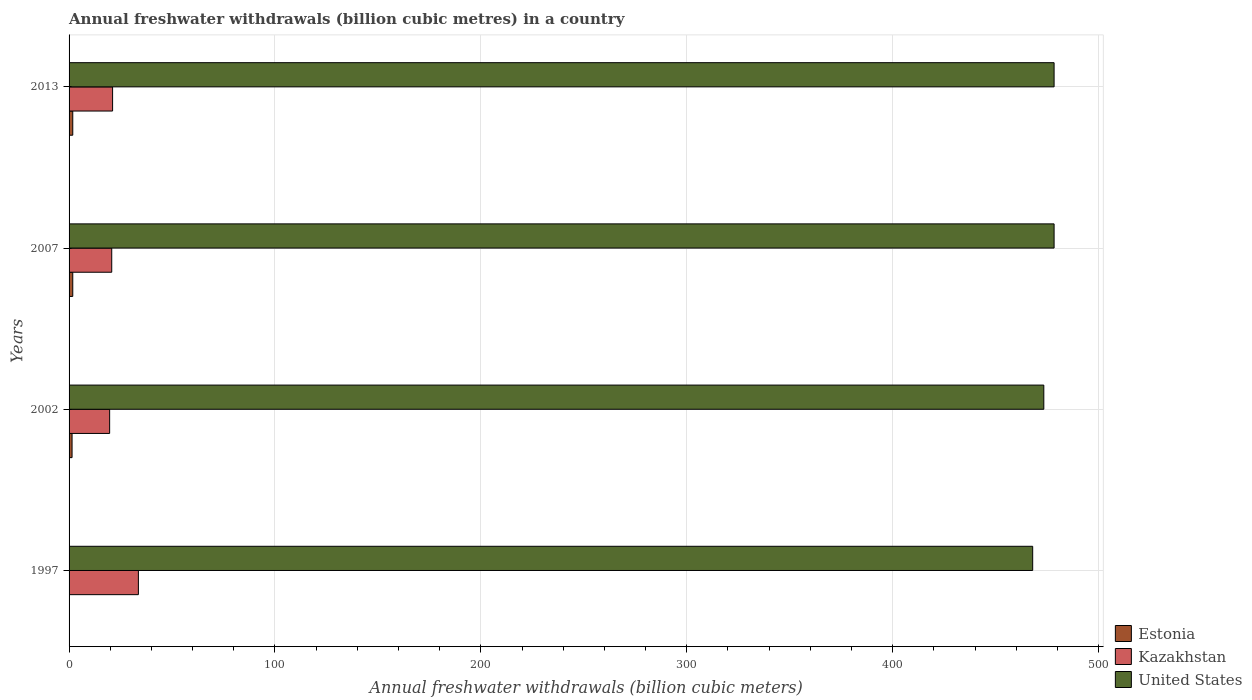How many bars are there on the 4th tick from the bottom?
Give a very brief answer. 3. What is the annual freshwater withdrawals in United States in 2013?
Your answer should be very brief. 478.4. Across all years, what is the maximum annual freshwater withdrawals in Kazakhstan?
Offer a very short reply. 33.67. Across all years, what is the minimum annual freshwater withdrawals in United States?
Your answer should be compact. 468. In which year was the annual freshwater withdrawals in Kazakhstan minimum?
Make the answer very short. 2002. What is the total annual freshwater withdrawals in Kazakhstan in the graph?
Keep it short and to the point. 95.23. What is the difference between the annual freshwater withdrawals in United States in 1997 and that in 2002?
Ensure brevity in your answer.  -5.4. What is the difference between the annual freshwater withdrawals in Kazakhstan in 2007 and the annual freshwater withdrawals in Estonia in 2002?
Your response must be concise. 19.26. What is the average annual freshwater withdrawals in Estonia per year?
Your answer should be compact. 1.3. In the year 1997, what is the difference between the annual freshwater withdrawals in United States and annual freshwater withdrawals in Kazakhstan?
Offer a terse response. 434.33. What is the ratio of the annual freshwater withdrawals in United States in 1997 to that in 2007?
Make the answer very short. 0.98. What is the difference between the highest and the second highest annual freshwater withdrawals in United States?
Provide a short and direct response. 0. What is the difference between the highest and the lowest annual freshwater withdrawals in Kazakhstan?
Keep it short and to the point. 13.97. What does the 2nd bar from the top in 2002 represents?
Your answer should be compact. Kazakhstan. What does the 2nd bar from the bottom in 2002 represents?
Your response must be concise. Kazakhstan. Is it the case that in every year, the sum of the annual freshwater withdrawals in United States and annual freshwater withdrawals in Kazakhstan is greater than the annual freshwater withdrawals in Estonia?
Make the answer very short. Yes. How many bars are there?
Make the answer very short. 12. Are all the bars in the graph horizontal?
Your answer should be compact. Yes. What is the difference between two consecutive major ticks on the X-axis?
Provide a succinct answer. 100. Are the values on the major ticks of X-axis written in scientific E-notation?
Offer a very short reply. No. Does the graph contain grids?
Make the answer very short. Yes. Where does the legend appear in the graph?
Your response must be concise. Bottom right. What is the title of the graph?
Provide a short and direct response. Annual freshwater withdrawals (billion cubic metres) in a country. Does "Ghana" appear as one of the legend labels in the graph?
Give a very brief answer. No. What is the label or title of the X-axis?
Provide a short and direct response. Annual freshwater withdrawals (billion cubic meters). What is the Annual freshwater withdrawals (billion cubic meters) of Estonia in 1997?
Give a very brief answer. 0.16. What is the Annual freshwater withdrawals (billion cubic meters) of Kazakhstan in 1997?
Your response must be concise. 33.67. What is the Annual freshwater withdrawals (billion cubic meters) of United States in 1997?
Offer a very short reply. 468. What is the Annual freshwater withdrawals (billion cubic meters) in Estonia in 2002?
Ensure brevity in your answer.  1.46. What is the Annual freshwater withdrawals (billion cubic meters) in United States in 2002?
Keep it short and to the point. 473.4. What is the Annual freshwater withdrawals (billion cubic meters) in Estonia in 2007?
Give a very brief answer. 1.8. What is the Annual freshwater withdrawals (billion cubic meters) in Kazakhstan in 2007?
Keep it short and to the point. 20.72. What is the Annual freshwater withdrawals (billion cubic meters) of United States in 2007?
Your response must be concise. 478.4. What is the Annual freshwater withdrawals (billion cubic meters) of Estonia in 2013?
Ensure brevity in your answer.  1.8. What is the Annual freshwater withdrawals (billion cubic meters) in Kazakhstan in 2013?
Offer a terse response. 21.14. What is the Annual freshwater withdrawals (billion cubic meters) in United States in 2013?
Provide a succinct answer. 478.4. Across all years, what is the maximum Annual freshwater withdrawals (billion cubic meters) in Estonia?
Your response must be concise. 1.8. Across all years, what is the maximum Annual freshwater withdrawals (billion cubic meters) of Kazakhstan?
Your response must be concise. 33.67. Across all years, what is the maximum Annual freshwater withdrawals (billion cubic meters) in United States?
Ensure brevity in your answer.  478.4. Across all years, what is the minimum Annual freshwater withdrawals (billion cubic meters) of Estonia?
Offer a very short reply. 0.16. Across all years, what is the minimum Annual freshwater withdrawals (billion cubic meters) of United States?
Offer a very short reply. 468. What is the total Annual freshwater withdrawals (billion cubic meters) in Estonia in the graph?
Your answer should be very brief. 5.21. What is the total Annual freshwater withdrawals (billion cubic meters) of Kazakhstan in the graph?
Keep it short and to the point. 95.23. What is the total Annual freshwater withdrawals (billion cubic meters) of United States in the graph?
Offer a terse response. 1898.2. What is the difference between the Annual freshwater withdrawals (billion cubic meters) of Estonia in 1997 and that in 2002?
Your answer should be compact. -1.3. What is the difference between the Annual freshwater withdrawals (billion cubic meters) of Kazakhstan in 1997 and that in 2002?
Ensure brevity in your answer.  13.97. What is the difference between the Annual freshwater withdrawals (billion cubic meters) in United States in 1997 and that in 2002?
Keep it short and to the point. -5.4. What is the difference between the Annual freshwater withdrawals (billion cubic meters) in Estonia in 1997 and that in 2007?
Your answer should be very brief. -1.64. What is the difference between the Annual freshwater withdrawals (billion cubic meters) of Kazakhstan in 1997 and that in 2007?
Provide a short and direct response. 12.95. What is the difference between the Annual freshwater withdrawals (billion cubic meters) in Estonia in 1997 and that in 2013?
Your answer should be very brief. -1.64. What is the difference between the Annual freshwater withdrawals (billion cubic meters) in Kazakhstan in 1997 and that in 2013?
Ensure brevity in your answer.  12.53. What is the difference between the Annual freshwater withdrawals (billion cubic meters) in United States in 1997 and that in 2013?
Offer a terse response. -10.4. What is the difference between the Annual freshwater withdrawals (billion cubic meters) in Estonia in 2002 and that in 2007?
Provide a succinct answer. -0.34. What is the difference between the Annual freshwater withdrawals (billion cubic meters) of Kazakhstan in 2002 and that in 2007?
Ensure brevity in your answer.  -1.02. What is the difference between the Annual freshwater withdrawals (billion cubic meters) of Estonia in 2002 and that in 2013?
Give a very brief answer. -0.34. What is the difference between the Annual freshwater withdrawals (billion cubic meters) in Kazakhstan in 2002 and that in 2013?
Ensure brevity in your answer.  -1.44. What is the difference between the Annual freshwater withdrawals (billion cubic meters) of United States in 2002 and that in 2013?
Keep it short and to the point. -5. What is the difference between the Annual freshwater withdrawals (billion cubic meters) in Estonia in 2007 and that in 2013?
Your response must be concise. 0. What is the difference between the Annual freshwater withdrawals (billion cubic meters) in Kazakhstan in 2007 and that in 2013?
Offer a very short reply. -0.42. What is the difference between the Annual freshwater withdrawals (billion cubic meters) in Estonia in 1997 and the Annual freshwater withdrawals (billion cubic meters) in Kazakhstan in 2002?
Offer a terse response. -19.54. What is the difference between the Annual freshwater withdrawals (billion cubic meters) of Estonia in 1997 and the Annual freshwater withdrawals (billion cubic meters) of United States in 2002?
Provide a short and direct response. -473.24. What is the difference between the Annual freshwater withdrawals (billion cubic meters) of Kazakhstan in 1997 and the Annual freshwater withdrawals (billion cubic meters) of United States in 2002?
Your answer should be very brief. -439.73. What is the difference between the Annual freshwater withdrawals (billion cubic meters) in Estonia in 1997 and the Annual freshwater withdrawals (billion cubic meters) in Kazakhstan in 2007?
Provide a short and direct response. -20.56. What is the difference between the Annual freshwater withdrawals (billion cubic meters) of Estonia in 1997 and the Annual freshwater withdrawals (billion cubic meters) of United States in 2007?
Ensure brevity in your answer.  -478.24. What is the difference between the Annual freshwater withdrawals (billion cubic meters) of Kazakhstan in 1997 and the Annual freshwater withdrawals (billion cubic meters) of United States in 2007?
Keep it short and to the point. -444.73. What is the difference between the Annual freshwater withdrawals (billion cubic meters) in Estonia in 1997 and the Annual freshwater withdrawals (billion cubic meters) in Kazakhstan in 2013?
Ensure brevity in your answer.  -20.98. What is the difference between the Annual freshwater withdrawals (billion cubic meters) in Estonia in 1997 and the Annual freshwater withdrawals (billion cubic meters) in United States in 2013?
Keep it short and to the point. -478.24. What is the difference between the Annual freshwater withdrawals (billion cubic meters) of Kazakhstan in 1997 and the Annual freshwater withdrawals (billion cubic meters) of United States in 2013?
Your answer should be very brief. -444.73. What is the difference between the Annual freshwater withdrawals (billion cubic meters) in Estonia in 2002 and the Annual freshwater withdrawals (billion cubic meters) in Kazakhstan in 2007?
Make the answer very short. -19.26. What is the difference between the Annual freshwater withdrawals (billion cubic meters) in Estonia in 2002 and the Annual freshwater withdrawals (billion cubic meters) in United States in 2007?
Offer a terse response. -476.94. What is the difference between the Annual freshwater withdrawals (billion cubic meters) in Kazakhstan in 2002 and the Annual freshwater withdrawals (billion cubic meters) in United States in 2007?
Ensure brevity in your answer.  -458.7. What is the difference between the Annual freshwater withdrawals (billion cubic meters) in Estonia in 2002 and the Annual freshwater withdrawals (billion cubic meters) in Kazakhstan in 2013?
Keep it short and to the point. -19.68. What is the difference between the Annual freshwater withdrawals (billion cubic meters) in Estonia in 2002 and the Annual freshwater withdrawals (billion cubic meters) in United States in 2013?
Your response must be concise. -476.94. What is the difference between the Annual freshwater withdrawals (billion cubic meters) in Kazakhstan in 2002 and the Annual freshwater withdrawals (billion cubic meters) in United States in 2013?
Your response must be concise. -458.7. What is the difference between the Annual freshwater withdrawals (billion cubic meters) of Estonia in 2007 and the Annual freshwater withdrawals (billion cubic meters) of Kazakhstan in 2013?
Offer a very short reply. -19.34. What is the difference between the Annual freshwater withdrawals (billion cubic meters) of Estonia in 2007 and the Annual freshwater withdrawals (billion cubic meters) of United States in 2013?
Provide a succinct answer. -476.6. What is the difference between the Annual freshwater withdrawals (billion cubic meters) in Kazakhstan in 2007 and the Annual freshwater withdrawals (billion cubic meters) in United States in 2013?
Offer a very short reply. -457.68. What is the average Annual freshwater withdrawals (billion cubic meters) in Estonia per year?
Your answer should be compact. 1.3. What is the average Annual freshwater withdrawals (billion cubic meters) in Kazakhstan per year?
Provide a succinct answer. 23.81. What is the average Annual freshwater withdrawals (billion cubic meters) of United States per year?
Your response must be concise. 474.55. In the year 1997, what is the difference between the Annual freshwater withdrawals (billion cubic meters) of Estonia and Annual freshwater withdrawals (billion cubic meters) of Kazakhstan?
Offer a very short reply. -33.51. In the year 1997, what is the difference between the Annual freshwater withdrawals (billion cubic meters) in Estonia and Annual freshwater withdrawals (billion cubic meters) in United States?
Offer a terse response. -467.84. In the year 1997, what is the difference between the Annual freshwater withdrawals (billion cubic meters) of Kazakhstan and Annual freshwater withdrawals (billion cubic meters) of United States?
Your response must be concise. -434.33. In the year 2002, what is the difference between the Annual freshwater withdrawals (billion cubic meters) of Estonia and Annual freshwater withdrawals (billion cubic meters) of Kazakhstan?
Ensure brevity in your answer.  -18.24. In the year 2002, what is the difference between the Annual freshwater withdrawals (billion cubic meters) in Estonia and Annual freshwater withdrawals (billion cubic meters) in United States?
Offer a terse response. -471.94. In the year 2002, what is the difference between the Annual freshwater withdrawals (billion cubic meters) in Kazakhstan and Annual freshwater withdrawals (billion cubic meters) in United States?
Offer a very short reply. -453.7. In the year 2007, what is the difference between the Annual freshwater withdrawals (billion cubic meters) of Estonia and Annual freshwater withdrawals (billion cubic meters) of Kazakhstan?
Provide a succinct answer. -18.92. In the year 2007, what is the difference between the Annual freshwater withdrawals (billion cubic meters) in Estonia and Annual freshwater withdrawals (billion cubic meters) in United States?
Your response must be concise. -476.6. In the year 2007, what is the difference between the Annual freshwater withdrawals (billion cubic meters) of Kazakhstan and Annual freshwater withdrawals (billion cubic meters) of United States?
Your answer should be compact. -457.68. In the year 2013, what is the difference between the Annual freshwater withdrawals (billion cubic meters) in Estonia and Annual freshwater withdrawals (billion cubic meters) in Kazakhstan?
Ensure brevity in your answer.  -19.34. In the year 2013, what is the difference between the Annual freshwater withdrawals (billion cubic meters) in Estonia and Annual freshwater withdrawals (billion cubic meters) in United States?
Provide a succinct answer. -476.6. In the year 2013, what is the difference between the Annual freshwater withdrawals (billion cubic meters) in Kazakhstan and Annual freshwater withdrawals (billion cubic meters) in United States?
Offer a very short reply. -457.26. What is the ratio of the Annual freshwater withdrawals (billion cubic meters) in Estonia in 1997 to that in 2002?
Keep it short and to the point. 0.11. What is the ratio of the Annual freshwater withdrawals (billion cubic meters) of Kazakhstan in 1997 to that in 2002?
Provide a short and direct response. 1.71. What is the ratio of the Annual freshwater withdrawals (billion cubic meters) in United States in 1997 to that in 2002?
Ensure brevity in your answer.  0.99. What is the ratio of the Annual freshwater withdrawals (billion cubic meters) in Estonia in 1997 to that in 2007?
Your response must be concise. 0.09. What is the ratio of the Annual freshwater withdrawals (billion cubic meters) of Kazakhstan in 1997 to that in 2007?
Offer a very short reply. 1.62. What is the ratio of the Annual freshwater withdrawals (billion cubic meters) of United States in 1997 to that in 2007?
Provide a succinct answer. 0.98. What is the ratio of the Annual freshwater withdrawals (billion cubic meters) in Estonia in 1997 to that in 2013?
Give a very brief answer. 0.09. What is the ratio of the Annual freshwater withdrawals (billion cubic meters) of Kazakhstan in 1997 to that in 2013?
Ensure brevity in your answer.  1.59. What is the ratio of the Annual freshwater withdrawals (billion cubic meters) in United States in 1997 to that in 2013?
Your answer should be very brief. 0.98. What is the ratio of the Annual freshwater withdrawals (billion cubic meters) in Estonia in 2002 to that in 2007?
Give a very brief answer. 0.81. What is the ratio of the Annual freshwater withdrawals (billion cubic meters) in Kazakhstan in 2002 to that in 2007?
Provide a succinct answer. 0.95. What is the ratio of the Annual freshwater withdrawals (billion cubic meters) in United States in 2002 to that in 2007?
Ensure brevity in your answer.  0.99. What is the ratio of the Annual freshwater withdrawals (billion cubic meters) in Estonia in 2002 to that in 2013?
Your response must be concise. 0.81. What is the ratio of the Annual freshwater withdrawals (billion cubic meters) in Kazakhstan in 2002 to that in 2013?
Keep it short and to the point. 0.93. What is the ratio of the Annual freshwater withdrawals (billion cubic meters) in United States in 2002 to that in 2013?
Provide a short and direct response. 0.99. What is the ratio of the Annual freshwater withdrawals (billion cubic meters) of Kazakhstan in 2007 to that in 2013?
Your answer should be very brief. 0.98. What is the difference between the highest and the second highest Annual freshwater withdrawals (billion cubic meters) of Estonia?
Your answer should be compact. 0. What is the difference between the highest and the second highest Annual freshwater withdrawals (billion cubic meters) of Kazakhstan?
Keep it short and to the point. 12.53. What is the difference between the highest and the second highest Annual freshwater withdrawals (billion cubic meters) of United States?
Make the answer very short. 0. What is the difference between the highest and the lowest Annual freshwater withdrawals (billion cubic meters) of Estonia?
Make the answer very short. 1.64. What is the difference between the highest and the lowest Annual freshwater withdrawals (billion cubic meters) in Kazakhstan?
Make the answer very short. 13.97. 